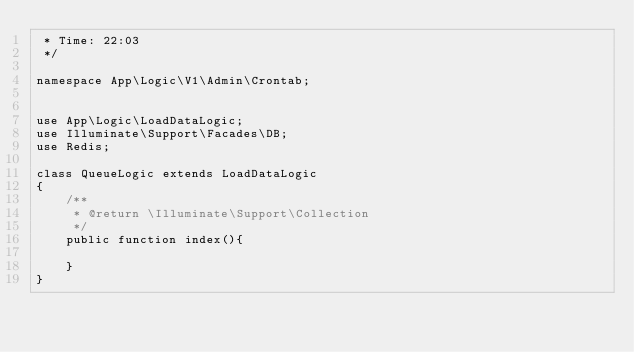Convert code to text. <code><loc_0><loc_0><loc_500><loc_500><_PHP_> * Time: 22:03
 */

namespace App\Logic\V1\Admin\Crontab;


use App\Logic\LoadDataLogic;
use Illuminate\Support\Facades\DB;
use Redis;

class QueueLogic extends LoadDataLogic
{
    /**
     * @return \Illuminate\Support\Collection
     */
    public function index(){

    }
}</code> 